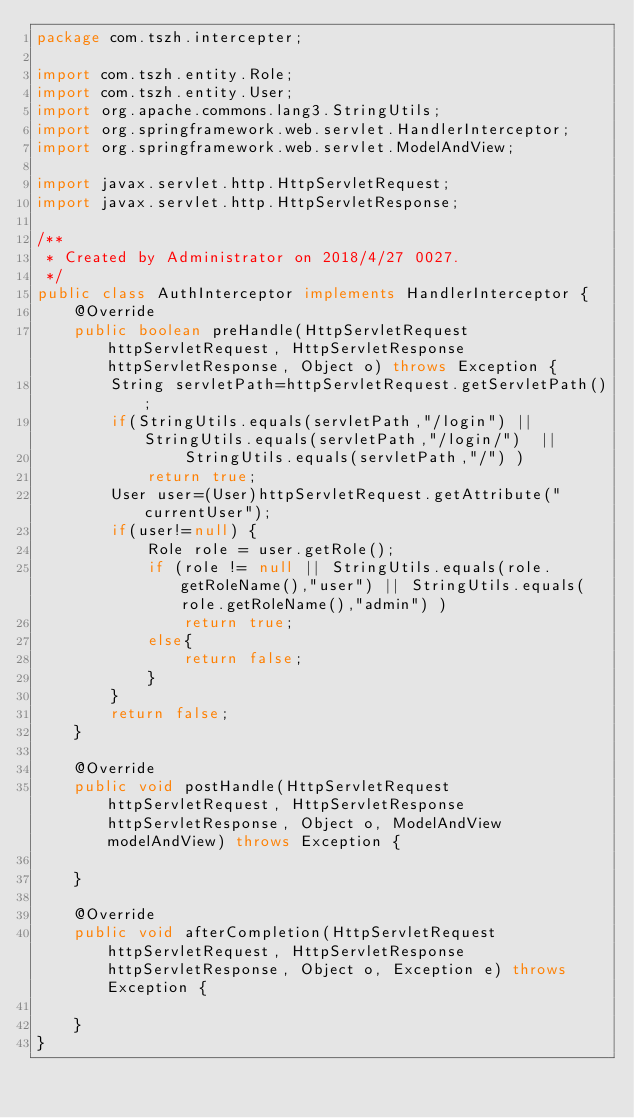Convert code to text. <code><loc_0><loc_0><loc_500><loc_500><_Java_>package com.tszh.intercepter;

import com.tszh.entity.Role;
import com.tszh.entity.User;
import org.apache.commons.lang3.StringUtils;
import org.springframework.web.servlet.HandlerInterceptor;
import org.springframework.web.servlet.ModelAndView;

import javax.servlet.http.HttpServletRequest;
import javax.servlet.http.HttpServletResponse;

/**
 * Created by Administrator on 2018/4/27 0027.
 */
public class AuthInterceptor implements HandlerInterceptor {
    @Override
    public boolean preHandle(HttpServletRequest httpServletRequest, HttpServletResponse httpServletResponse, Object o) throws Exception {
        String servletPath=httpServletRequest.getServletPath();
        if(StringUtils.equals(servletPath,"/login") || StringUtils.equals(servletPath,"/login/")  ||
                StringUtils.equals(servletPath,"/") )
            return true;
        User user=(User)httpServletRequest.getAttribute("currentUser");
        if(user!=null) {
            Role role = user.getRole();
            if (role != null || StringUtils.equals(role.getRoleName(),"user") || StringUtils.equals(role.getRoleName(),"admin") )
                return true;
            else{
                return false;
            }
        }
        return false;
    }

    @Override
    public void postHandle(HttpServletRequest httpServletRequest, HttpServletResponse httpServletResponse, Object o, ModelAndView modelAndView) throws Exception {

    }

    @Override
    public void afterCompletion(HttpServletRequest httpServletRequest, HttpServletResponse httpServletResponse, Object o, Exception e) throws Exception {

    }
}
</code> 